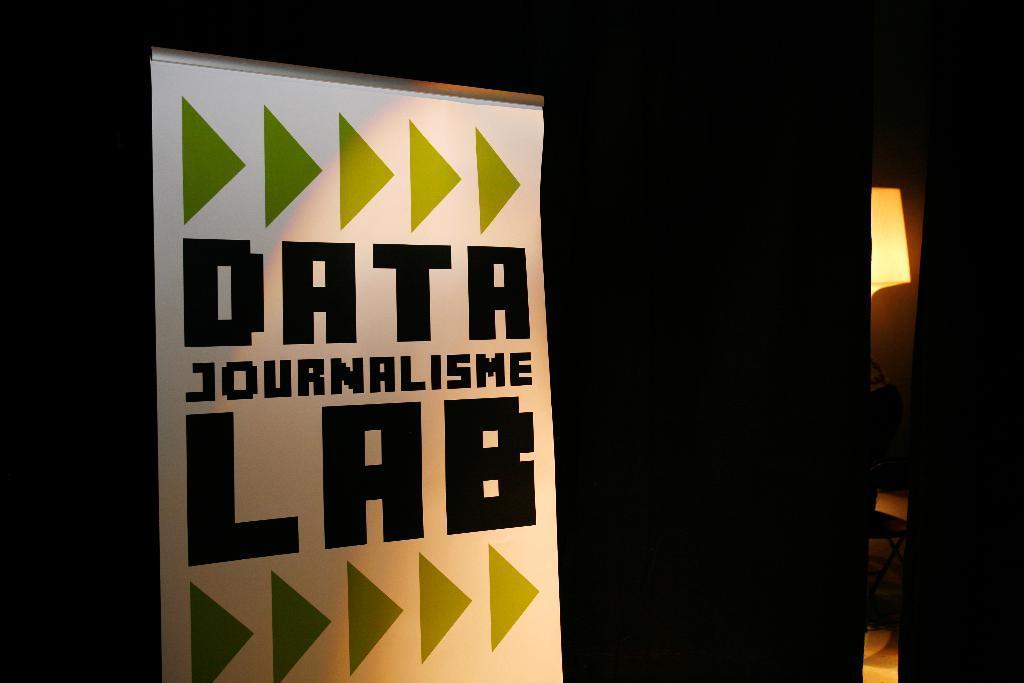Please provide a concise description of this image. In this image I can see a banner which is white in color and on the banner I can see few words written with black color and I can see the dark background, a lamp and a brown colored object. 